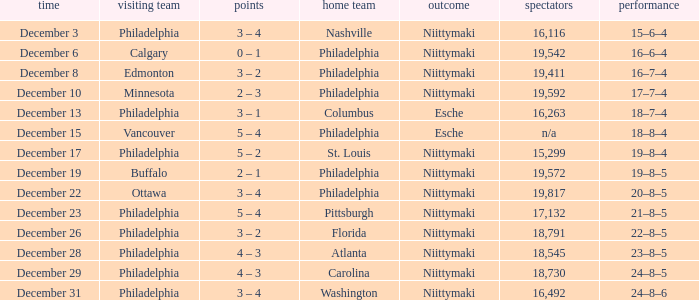What was the score when the attendance was 18,545? 4 – 3. 